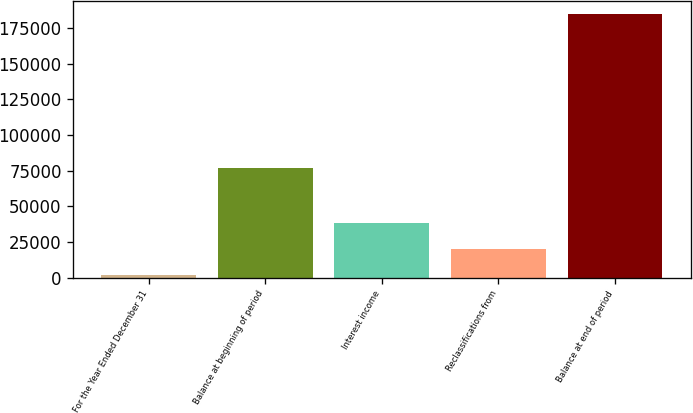Convert chart to OTSL. <chart><loc_0><loc_0><loc_500><loc_500><bar_chart><fcel>For the Year Ended December 31<fcel>Balance at beginning of period<fcel>Interest income<fcel>Reclassifications from<fcel>Balance at end of period<nl><fcel>2015<fcel>76518<fcel>38535.6<fcel>20275.3<fcel>184618<nl></chart> 